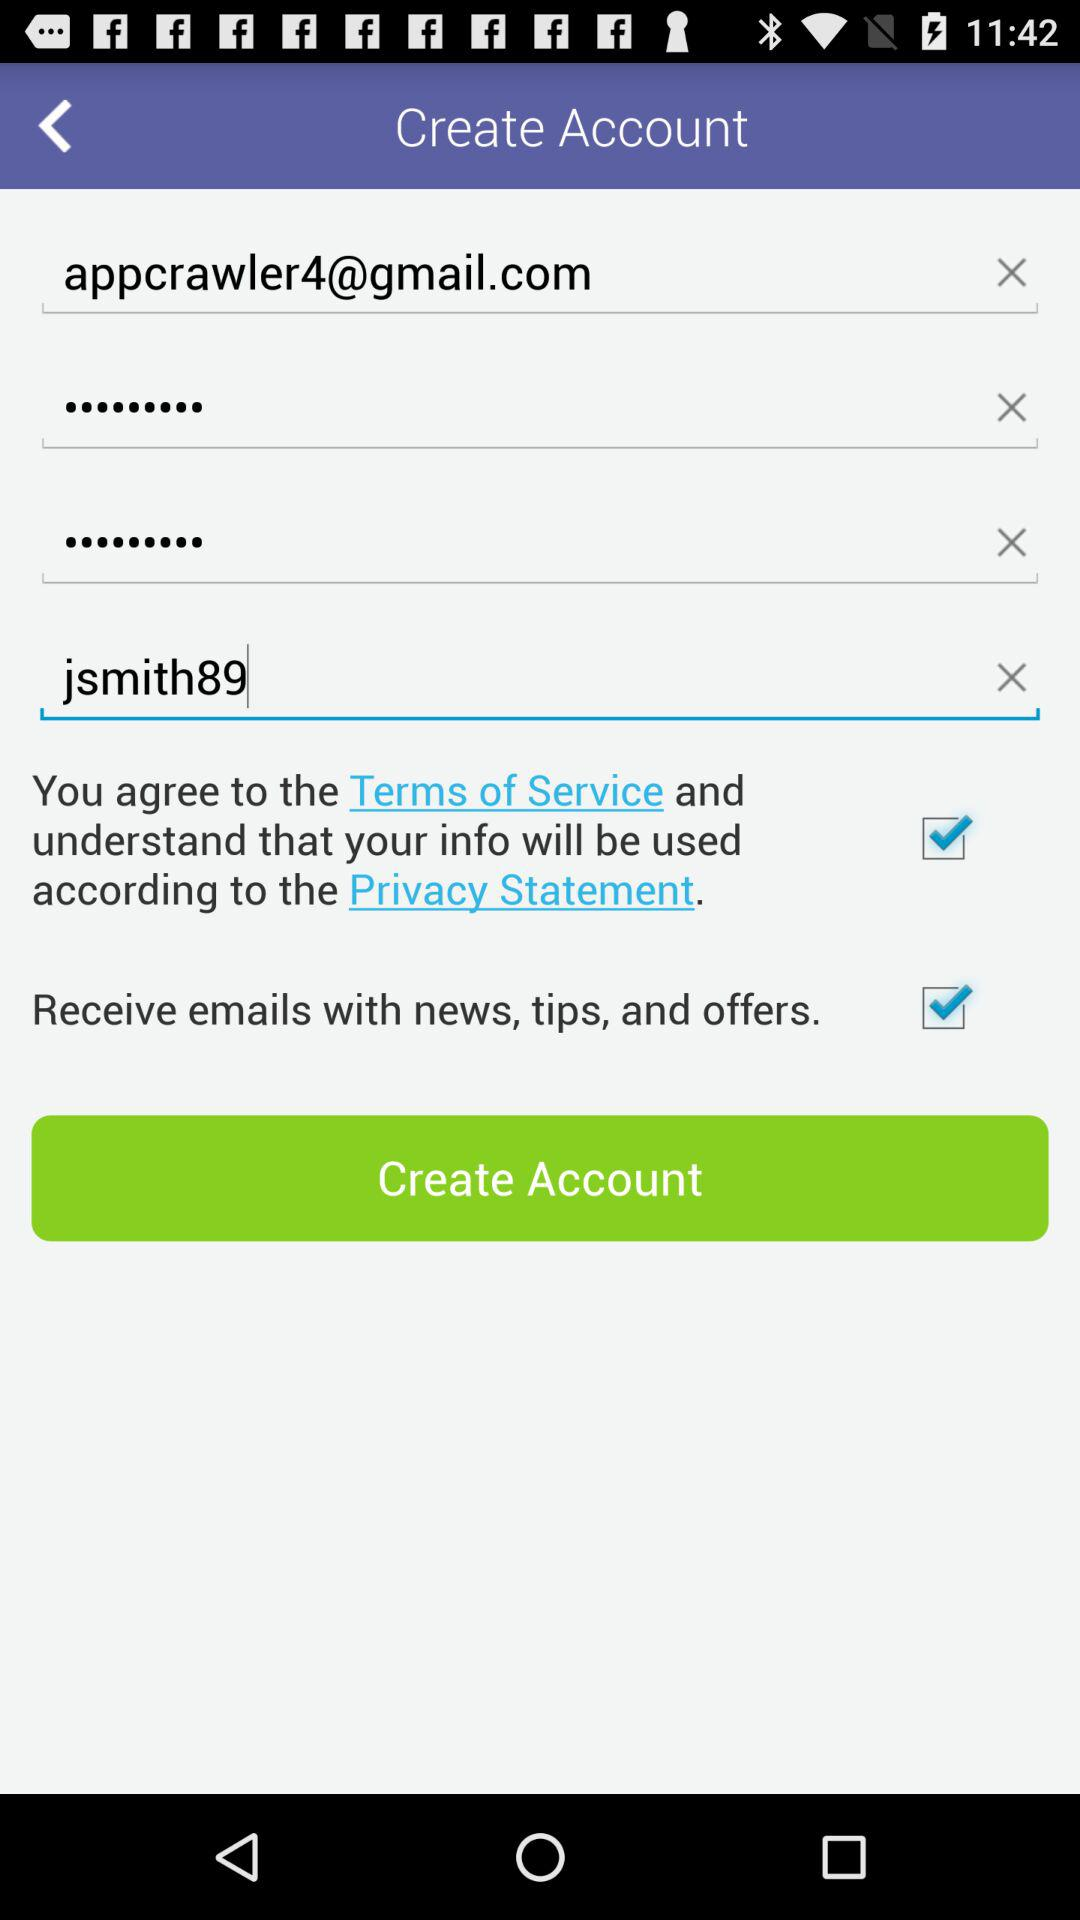What is the status of the "Receive emails with news, tips, and offers."? The status of the "Receive emails with news, tips, and offers." is "on". 